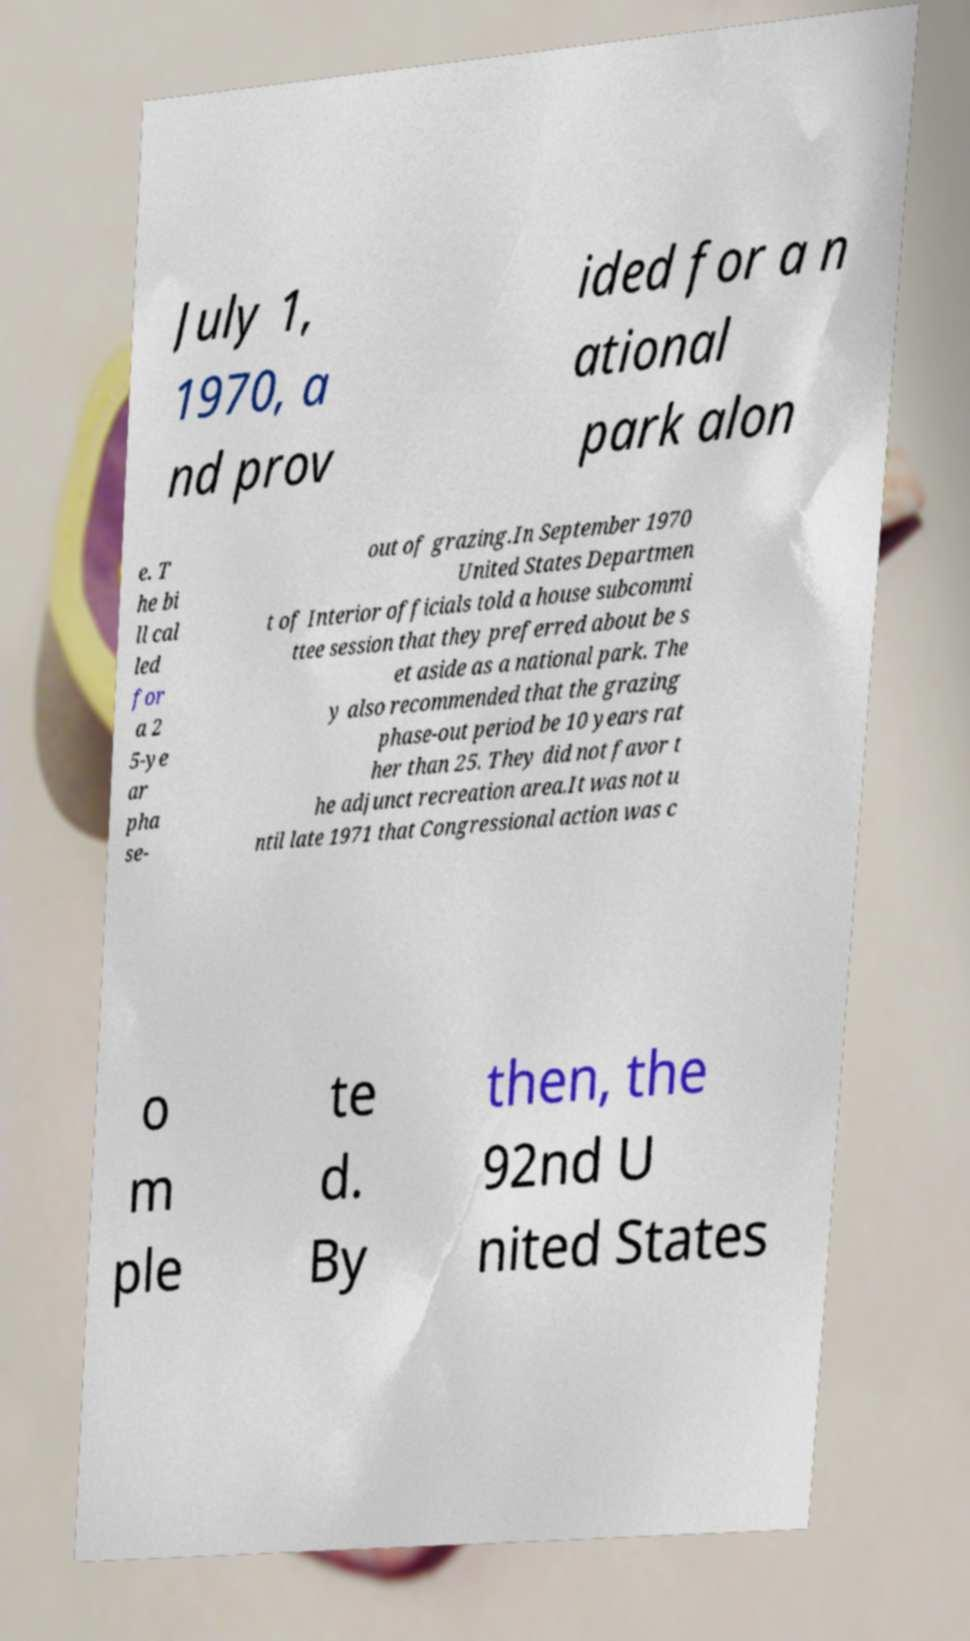Can you accurately transcribe the text from the provided image for me? July 1, 1970, a nd prov ided for a n ational park alon e. T he bi ll cal led for a 2 5-ye ar pha se- out of grazing.In September 1970 United States Departmen t of Interior officials told a house subcommi ttee session that they preferred about be s et aside as a national park. The y also recommended that the grazing phase-out period be 10 years rat her than 25. They did not favor t he adjunct recreation area.It was not u ntil late 1971 that Congressional action was c o m ple te d. By then, the 92nd U nited States 